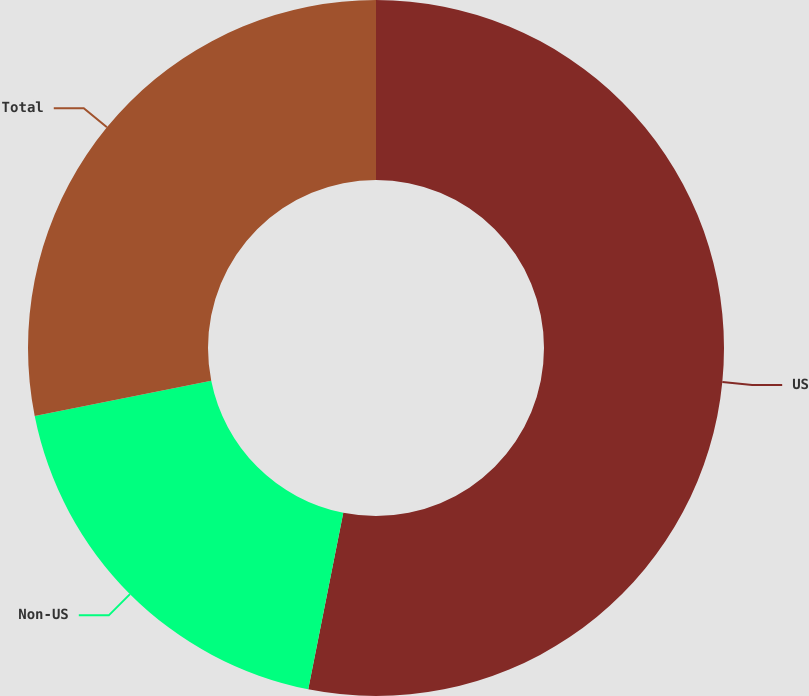Convert chart. <chart><loc_0><loc_0><loc_500><loc_500><pie_chart><fcel>US<fcel>Non-US<fcel>Total<nl><fcel>53.12%<fcel>18.75%<fcel>28.13%<nl></chart> 